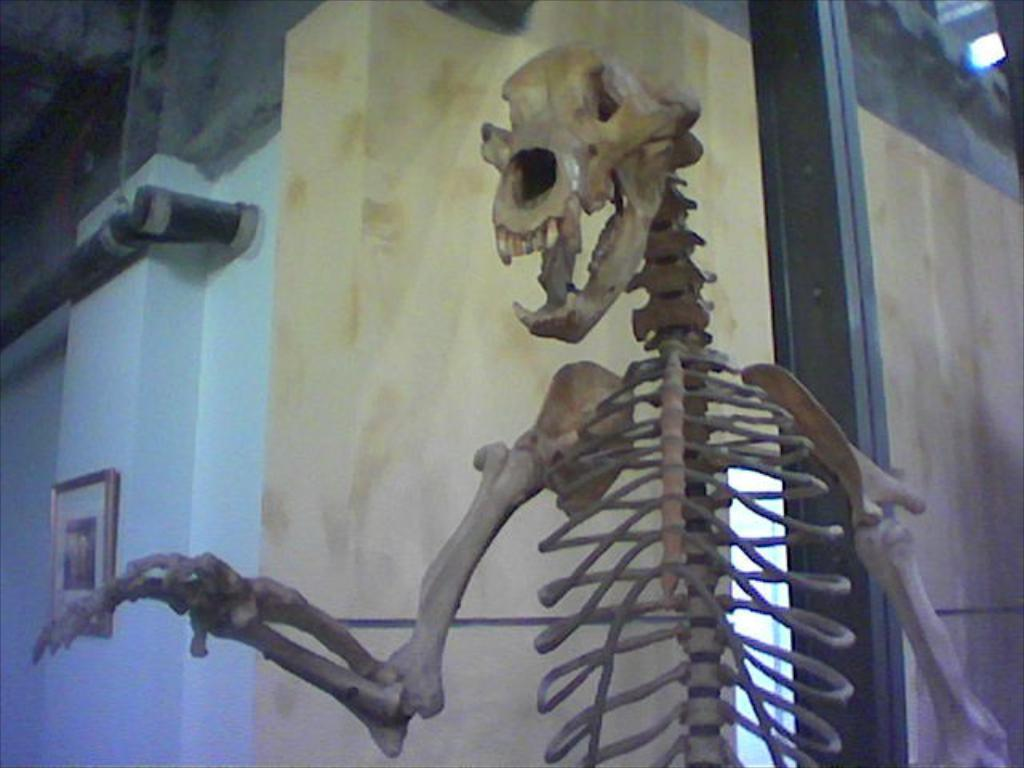What is the main subject in the foreground of the image? There is a skeleton of an animal in the foreground of the image. What can be seen in the background of the image? There is a wall, a pole, and a frame in the background of the image. How many babies are present in the image? There are no babies present in the image. What type of pear can be seen hanging from the pole in the background? There is no pear present in the image, and the pole does not have any fruit hanging from it. 